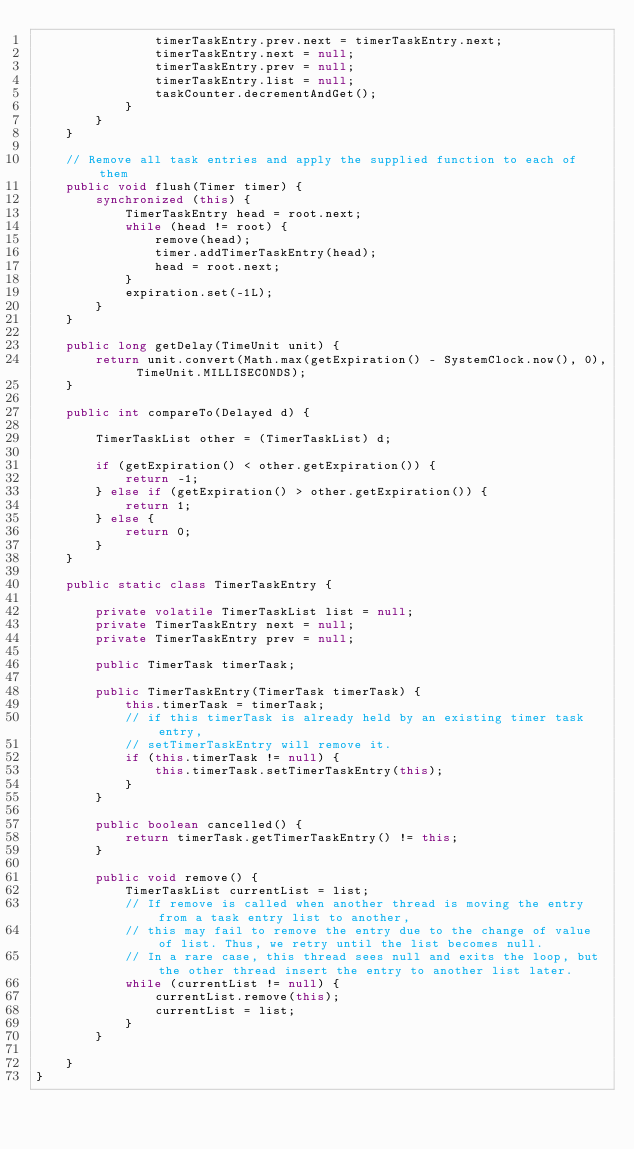Convert code to text. <code><loc_0><loc_0><loc_500><loc_500><_Java_>                timerTaskEntry.prev.next = timerTaskEntry.next;
                timerTaskEntry.next = null;
                timerTaskEntry.prev = null;
                timerTaskEntry.list = null;
                taskCounter.decrementAndGet();
            }
        }
    }

    // Remove all task entries and apply the supplied function to each of them
    public void flush(Timer timer) {
        synchronized (this) {
            TimerTaskEntry head = root.next;
            while (head != root) {
                remove(head);
                timer.addTimerTaskEntry(head);
                head = root.next;
            }
            expiration.set(-1L);
        }
    }

    public long getDelay(TimeUnit unit) {
        return unit.convert(Math.max(getExpiration() - SystemClock.now(), 0), TimeUnit.MILLISECONDS);
    }

    public int compareTo(Delayed d) {

        TimerTaskList other = (TimerTaskList) d;

        if (getExpiration() < other.getExpiration()) {
            return -1;
        } else if (getExpiration() > other.getExpiration()) {
            return 1;
        } else {
            return 0;
        }
    }

    public static class TimerTaskEntry {

        private volatile TimerTaskList list = null;
        private TimerTaskEntry next = null;
        private TimerTaskEntry prev = null;

        public TimerTask timerTask;

        public TimerTaskEntry(TimerTask timerTask) {
            this.timerTask = timerTask;
            // if this timerTask is already held by an existing timer task entry,
            // setTimerTaskEntry will remove it.
            if (this.timerTask != null) {
                this.timerTask.setTimerTaskEntry(this);
            }
        }

        public boolean cancelled() {
            return timerTask.getTimerTaskEntry() != this;
        }

        public void remove() {
            TimerTaskList currentList = list;
            // If remove is called when another thread is moving the entry from a task entry list to another,
            // this may fail to remove the entry due to the change of value of list. Thus, we retry until the list becomes null.
            // In a rare case, this thread sees null and exits the loop, but the other thread insert the entry to another list later.
            while (currentList != null) {
                currentList.remove(this);
                currentList = list;
            }
        }

    }
}
</code> 